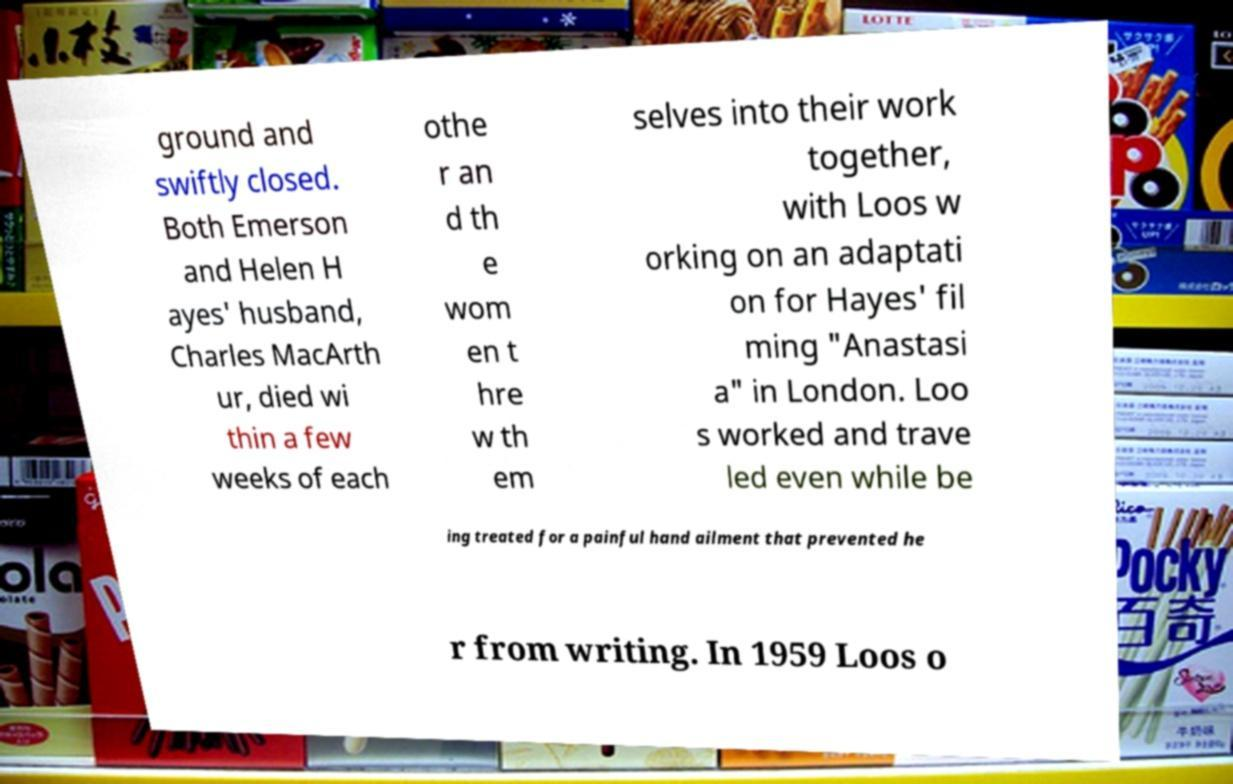Please read and relay the text visible in this image. What does it say? ground and swiftly closed. Both Emerson and Helen H ayes' husband, Charles MacArth ur, died wi thin a few weeks of each othe r an d th e wom en t hre w th em selves into their work together, with Loos w orking on an adaptati on for Hayes' fil ming "Anastasi a" in London. Loo s worked and trave led even while be ing treated for a painful hand ailment that prevented he r from writing. In 1959 Loos o 